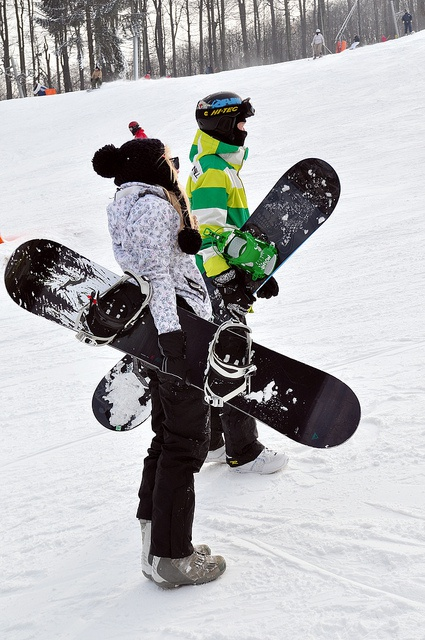Describe the objects in this image and their specific colors. I can see people in darkgray, black, lightgray, and gray tones, snowboard in darkgray, black, lightgray, and gray tones, people in darkgray, black, lightgray, and green tones, snowboard in darkgray, black, lightgray, and gray tones, and people in darkgray, lightgray, and gray tones in this image. 